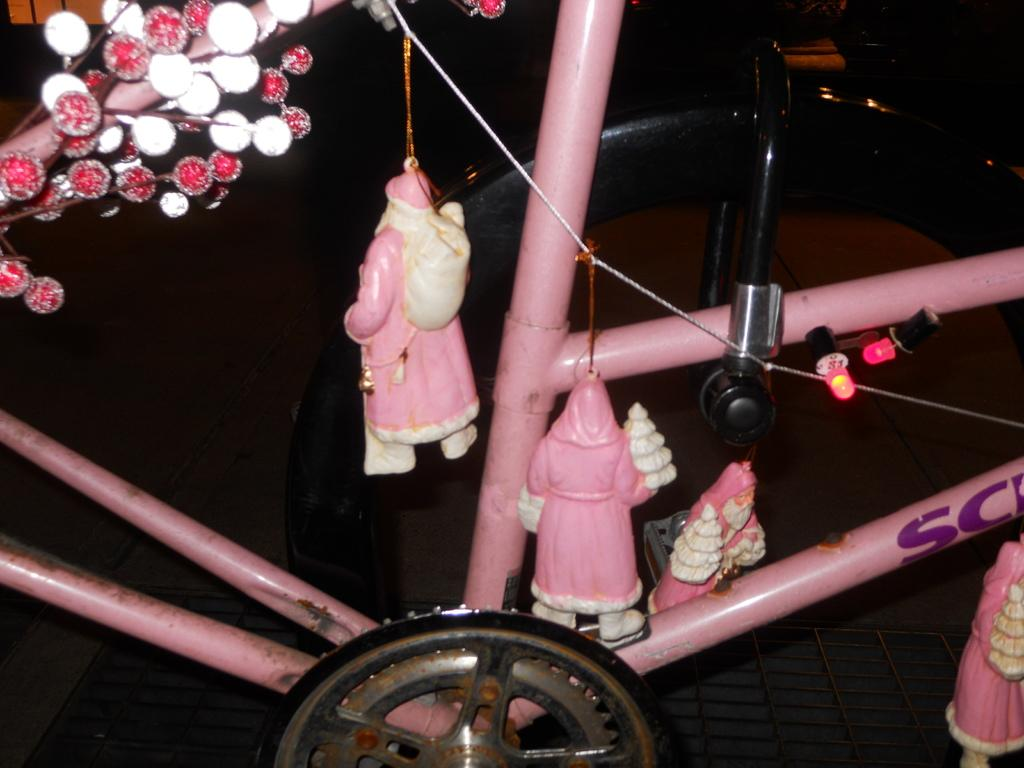What is the main mode of transportation in the image? There is a cycle in the image. What type of toys can be seen in the image? There are toys of Santa Claus in the image. Where is the hospital located in the image? There is no hospital present in the image. What time does the watch in the image show? There is no watch present in the image. 